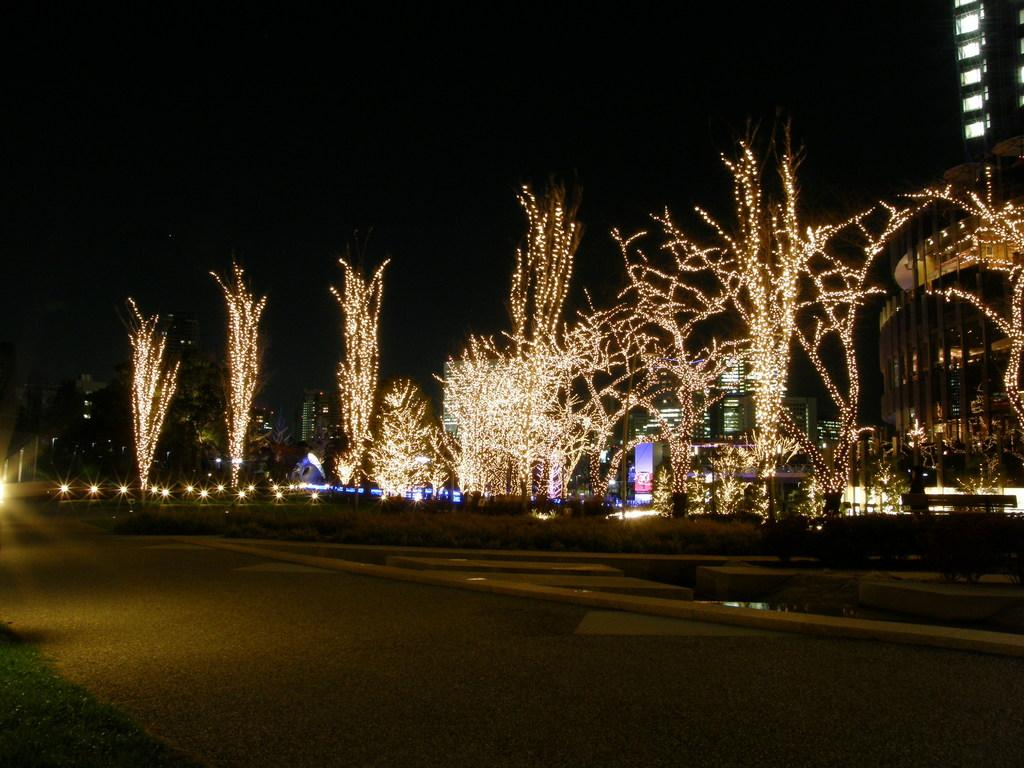What type of lights can be seen in the image? There are decor lights visible in the image. Where are the decor lights located? The decor lights are on trees, roads, and buildings in the image. What is visible in the sky in the image? The sky is visible in the image. What type of cart can be seen transporting oil in the image? There is no cart or oil present in the image. What type of place is depicted in the image? The image does not depict a specific place; it simply shows decor lights in various locations. 